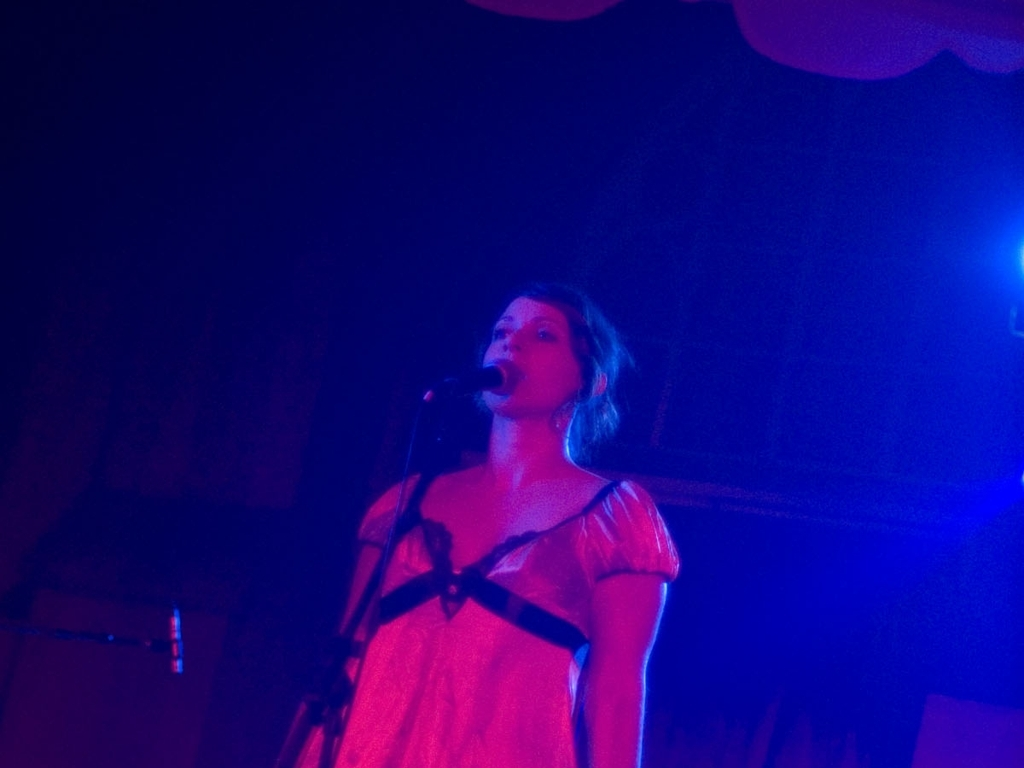Can you describe the setting in which this performer is? The performer is standing on what appears to be a stage with ambient lighting, mainly in shades of blue and purple, which hints at a small, cozy venue possibly for live music performances. 